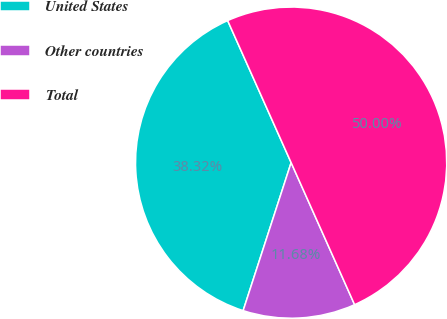Convert chart to OTSL. <chart><loc_0><loc_0><loc_500><loc_500><pie_chart><fcel>United States<fcel>Other countries<fcel>Total<nl><fcel>38.32%<fcel>11.68%<fcel>50.0%<nl></chart> 